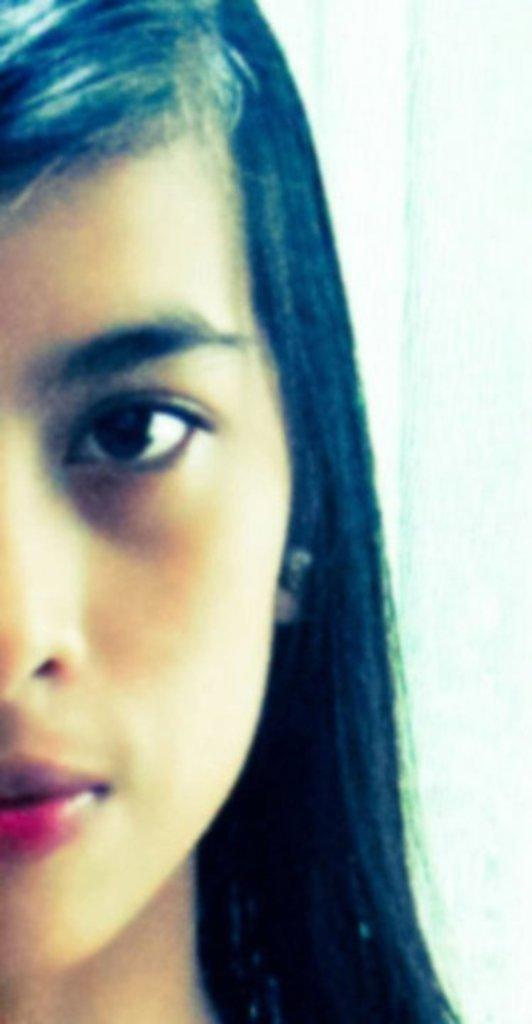Who is the main subject in the image? There is a woman in the image. Where is the woman located in the image? The woman is on the left side of the image. What color is the background of the image? The background of the image is white. What type of crib is visible in the image? There is no crib present in the image. How many levels can be seen in the building in the image? There is no building present in the image. 